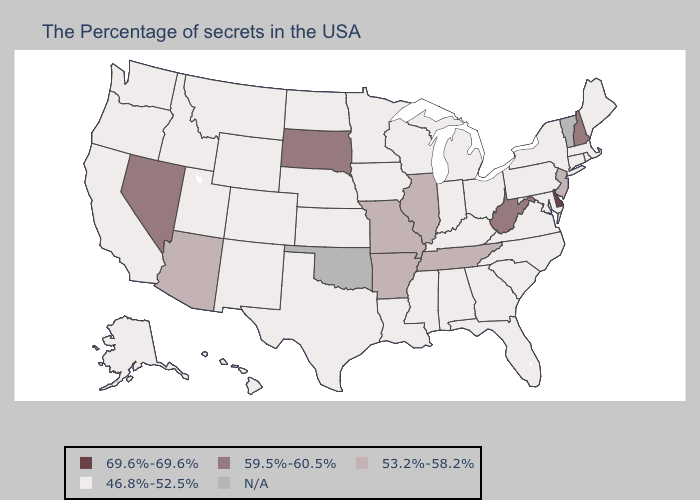What is the value of South Carolina?
Be succinct. 46.8%-52.5%. Does New Mexico have the lowest value in the USA?
Quick response, please. Yes. What is the highest value in states that border Virginia?
Quick response, please. 59.5%-60.5%. What is the lowest value in the Northeast?
Short answer required. 46.8%-52.5%. What is the highest value in the USA?
Quick response, please. 69.6%-69.6%. What is the value of Wisconsin?
Concise answer only. 46.8%-52.5%. Name the states that have a value in the range N/A?
Quick response, please. Vermont, Oklahoma. Is the legend a continuous bar?
Give a very brief answer. No. What is the value of Louisiana?
Be succinct. 46.8%-52.5%. Does Nevada have the highest value in the USA?
Answer briefly. No. Name the states that have a value in the range 46.8%-52.5%?
Quick response, please. Maine, Massachusetts, Rhode Island, Connecticut, New York, Maryland, Pennsylvania, Virginia, North Carolina, South Carolina, Ohio, Florida, Georgia, Michigan, Kentucky, Indiana, Alabama, Wisconsin, Mississippi, Louisiana, Minnesota, Iowa, Kansas, Nebraska, Texas, North Dakota, Wyoming, Colorado, New Mexico, Utah, Montana, Idaho, California, Washington, Oregon, Alaska, Hawaii. Among the states that border Idaho , does Washington have the lowest value?
Write a very short answer. Yes. 